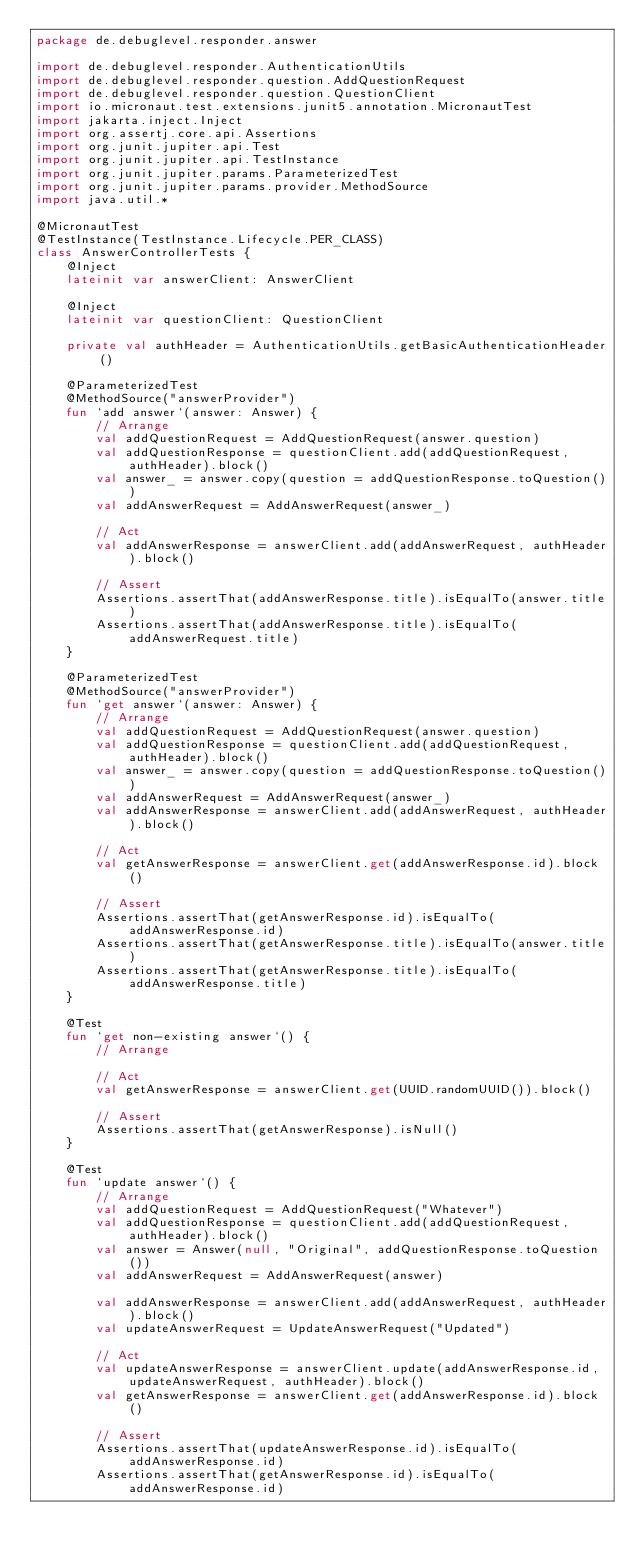Convert code to text. <code><loc_0><loc_0><loc_500><loc_500><_Kotlin_>package de.debuglevel.responder.answer

import de.debuglevel.responder.AuthenticationUtils
import de.debuglevel.responder.question.AddQuestionRequest
import de.debuglevel.responder.question.QuestionClient
import io.micronaut.test.extensions.junit5.annotation.MicronautTest
import jakarta.inject.Inject
import org.assertj.core.api.Assertions
import org.junit.jupiter.api.Test
import org.junit.jupiter.api.TestInstance
import org.junit.jupiter.params.ParameterizedTest
import org.junit.jupiter.params.provider.MethodSource
import java.util.*

@MicronautTest
@TestInstance(TestInstance.Lifecycle.PER_CLASS)
class AnswerControllerTests {
    @Inject
    lateinit var answerClient: AnswerClient

    @Inject
    lateinit var questionClient: QuestionClient

    private val authHeader = AuthenticationUtils.getBasicAuthenticationHeader()

    @ParameterizedTest
    @MethodSource("answerProvider")
    fun `add answer`(answer: Answer) {
        // Arrange
        val addQuestionRequest = AddQuestionRequest(answer.question)
        val addQuestionResponse = questionClient.add(addQuestionRequest, authHeader).block()
        val answer_ = answer.copy(question = addQuestionResponse.toQuestion())
        val addAnswerRequest = AddAnswerRequest(answer_)

        // Act
        val addAnswerResponse = answerClient.add(addAnswerRequest, authHeader).block()

        // Assert
        Assertions.assertThat(addAnswerResponse.title).isEqualTo(answer.title)
        Assertions.assertThat(addAnswerResponse.title).isEqualTo(addAnswerRequest.title)
    }

    @ParameterizedTest
    @MethodSource("answerProvider")
    fun `get answer`(answer: Answer) {
        // Arrange
        val addQuestionRequest = AddQuestionRequest(answer.question)
        val addQuestionResponse = questionClient.add(addQuestionRequest, authHeader).block()
        val answer_ = answer.copy(question = addQuestionResponse.toQuestion())
        val addAnswerRequest = AddAnswerRequest(answer_)
        val addAnswerResponse = answerClient.add(addAnswerRequest, authHeader).block()

        // Act
        val getAnswerResponse = answerClient.get(addAnswerResponse.id).block()

        // Assert
        Assertions.assertThat(getAnswerResponse.id).isEqualTo(addAnswerResponse.id)
        Assertions.assertThat(getAnswerResponse.title).isEqualTo(answer.title)
        Assertions.assertThat(getAnswerResponse.title).isEqualTo(addAnswerResponse.title)
    }

    @Test
    fun `get non-existing answer`() {
        // Arrange

        // Act
        val getAnswerResponse = answerClient.get(UUID.randomUUID()).block()

        // Assert
        Assertions.assertThat(getAnswerResponse).isNull()
    }

    @Test
    fun `update answer`() {
        // Arrange
        val addQuestionRequest = AddQuestionRequest("Whatever")
        val addQuestionResponse = questionClient.add(addQuestionRequest, authHeader).block()
        val answer = Answer(null, "Original", addQuestionResponse.toQuestion())
        val addAnswerRequest = AddAnswerRequest(answer)

        val addAnswerResponse = answerClient.add(addAnswerRequest, authHeader).block()
        val updateAnswerRequest = UpdateAnswerRequest("Updated")

        // Act
        val updateAnswerResponse = answerClient.update(addAnswerResponse.id, updateAnswerRequest, authHeader).block()
        val getAnswerResponse = answerClient.get(addAnswerResponse.id).block()

        // Assert
        Assertions.assertThat(updateAnswerResponse.id).isEqualTo(addAnswerResponse.id)
        Assertions.assertThat(getAnswerResponse.id).isEqualTo(addAnswerResponse.id)</code> 